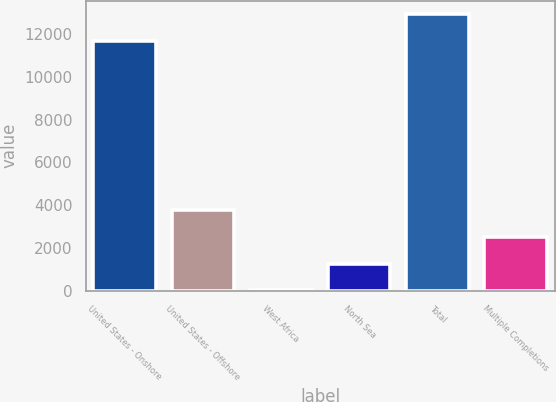<chart> <loc_0><loc_0><loc_500><loc_500><bar_chart><fcel>United States - Onshore<fcel>United States - Offshore<fcel>West Africa<fcel>North Sea<fcel>Total<fcel>Multiple Completions<nl><fcel>11664<fcel>3767<fcel>20<fcel>1269<fcel>12913<fcel>2518<nl></chart> 